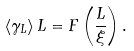<formula> <loc_0><loc_0><loc_500><loc_500>\left < \gamma _ { L } \right > L = F \left ( \frac { L } { \xi } \right ) .</formula> 